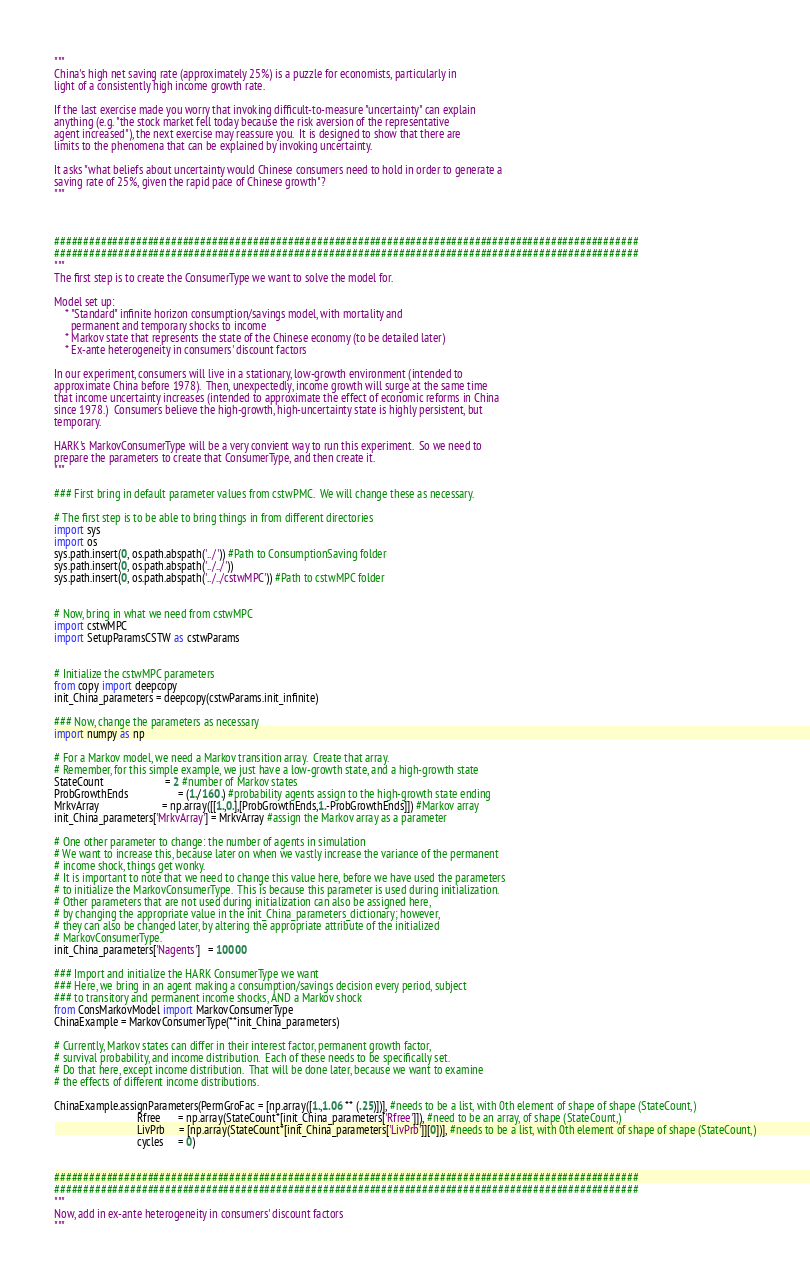<code> <loc_0><loc_0><loc_500><loc_500><_Python_>"""
China's high net saving rate (approximately 25%) is a puzzle for economists, particularly in 
light of a consistently high income growth rate.  

If the last exercise made you worry that invoking difficult-to-measure "uncertainty" can explain
anything (e.g. "the stock market fell today because the risk aversion of the representative 
agent increased"), the next exercise may reassure you.  It is designed to show that there are 
limits to the phenomena that can be explained by invoking uncertainty.
 
It asks "what beliefs about uncertainty would Chinese consumers need to hold in order to generate a
saving rate of 25%, given the rapid pace of Chinese growth"?
"""



####################################################################################################
####################################################################################################
"""
The first step is to create the ConsumerType we want to solve the model for.

Model set up:
    * "Standard" infinite horizon consumption/savings model, with mortality and 
      permanent and temporary shocks to income
    * Markov state that represents the state of the Chinese economy (to be detailed later)
    * Ex-ante heterogeneity in consumers' discount factors

In our experiment, consumers will live in a stationary, low-growth environment (intended to 
approximate China before 1978).  Then, unexpectedly, income growth will surge at the same time
that income uncertainty increases (intended to approximate the effect of economic reforms in China
since 1978.)  Consumers believe the high-growth, high-uncertainty state is highly persistent, but
temporary.

HARK's MarkovConsumerType will be a very convient way to run this experiment.  So we need to
prepare the parameters to create that ConsumerType, and then create it.
"""

### First bring in default parameter values from cstwPMC.  We will change these as necessary.

# The first step is to be able to bring things in from different directories
import sys 
import os
sys.path.insert(0, os.path.abspath('../')) #Path to ConsumptionSaving folder
sys.path.insert(0, os.path.abspath('../../'))
sys.path.insert(0, os.path.abspath('../../cstwMPC')) #Path to cstwMPC folder


# Now, bring in what we need from cstwMPC
import cstwMPC
import SetupParamsCSTW as cstwParams


# Initialize the cstwMPC parameters
from copy import deepcopy
init_China_parameters = deepcopy(cstwParams.init_infinite)

### Now, change the parameters as necessary
import numpy as np

# For a Markov model, we need a Markov transition array.  Create that array.
# Remember, for this simple example, we just have a low-growth state, and a high-growth state
StateCount                      = 2 #number of Markov states
ProbGrowthEnds                  = (1./160.) #probability agents assign to the high-growth state ending
MrkvArray                       = np.array([[1.,0.],[ProbGrowthEnds,1.-ProbGrowthEnds]]) #Markov array
init_China_parameters['MrkvArray'] = MrkvArray #assign the Markov array as a parameter

# One other parameter to change: the number of agents in simulation
# We want to increase this, because later on when we vastly increase the variance of the permanent
# income shock, things get wonky.
# It is important to note that we need to change this value here, before we have used the parameters
# to initialize the MarkovConsumerType.  This is because this parameter is used during initialization.
# Other parameters that are not used during initialization can also be assigned here,
# by changing the appropriate value in the init_China_parameters_dictionary; however,
# they can also be changed later, by altering the appropriate attribute of the initialized
# MarkovConsumerType.
init_China_parameters['Nagents']   = 10000

### Import and initialize the HARK ConsumerType we want 
### Here, we bring in an agent making a consumption/savings decision every period, subject
### to transitory and permanent income shocks, AND a Markov shock
from ConsMarkovModel import MarkovConsumerType
ChinaExample = MarkovConsumerType(**init_China_parameters)

# Currently, Markov states can differ in their interest factor, permanent growth factor, 
# survival probability, and income distribution.  Each of these needs to be specifically set.  
# Do that here, except income distribution.  That will be done later, because we want to examine
# the effects of different income distributions.

ChinaExample.assignParameters(PermGroFac = [np.array([1.,1.06 ** (.25)])], #needs to be a list, with 0th element of shape of shape (StateCount,)
                              Rfree      = np.array(StateCount*[init_China_parameters['Rfree']]), #need to be an array, of shape (StateCount,)
                              LivPrb     = [np.array(StateCount*[init_China_parameters['LivPrb']][0])], #needs to be a list, with 0th element of shape of shape (StateCount,)
                              cycles     = 0)


####################################################################################################
####################################################################################################
"""
Now, add in ex-ante heterogeneity in consumers' discount factors
"""
</code> 